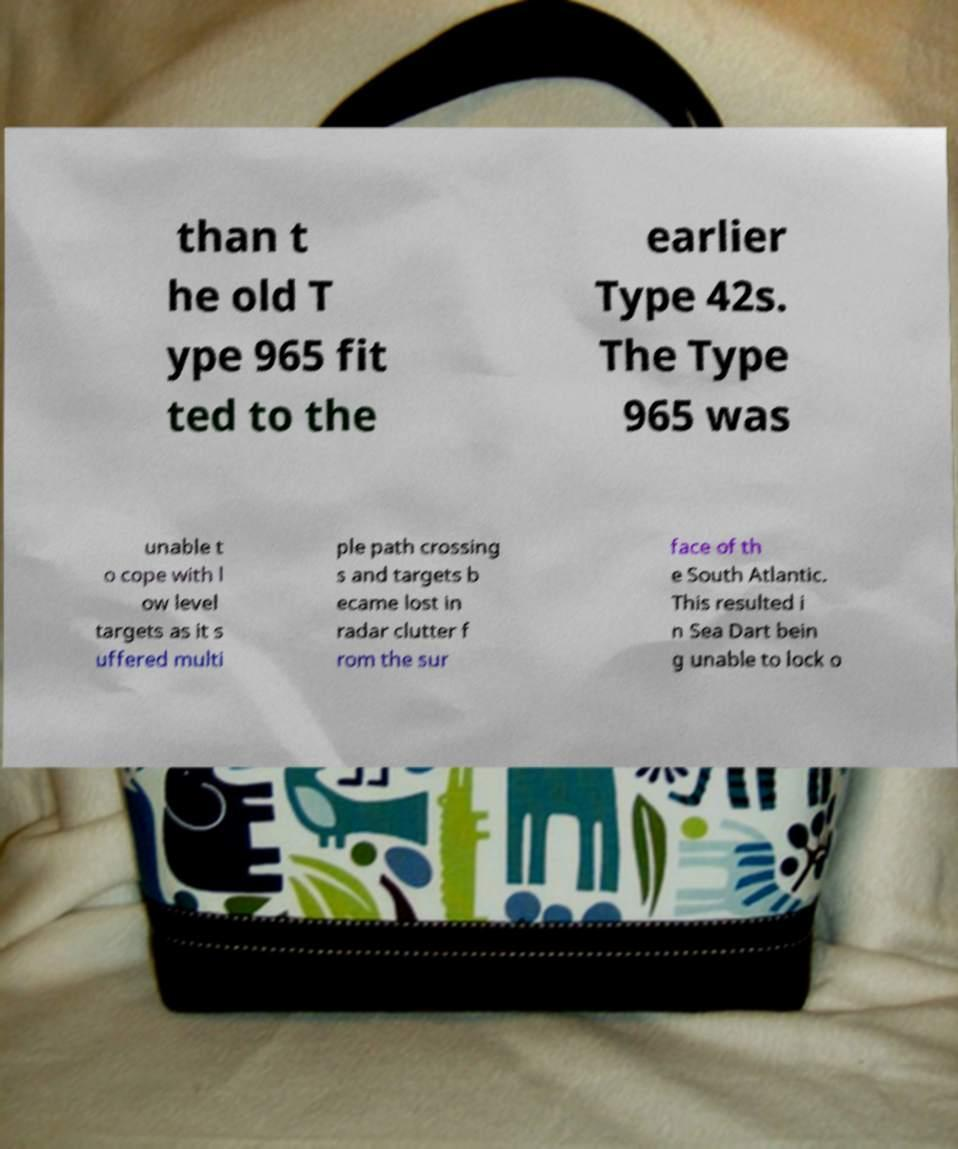Please identify and transcribe the text found in this image. than t he old T ype 965 fit ted to the earlier Type 42s. The Type 965 was unable t o cope with l ow level targets as it s uffered multi ple path crossing s and targets b ecame lost in radar clutter f rom the sur face of th e South Atlantic. This resulted i n Sea Dart bein g unable to lock o 